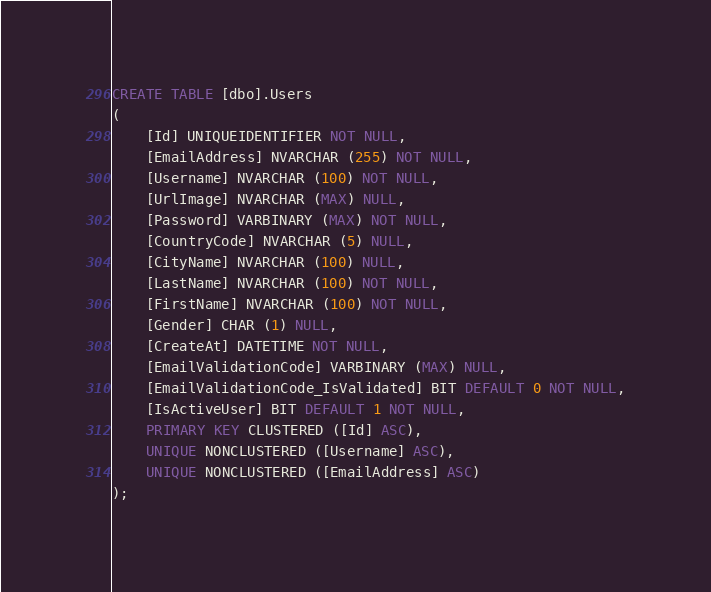<code> <loc_0><loc_0><loc_500><loc_500><_SQL_>CREATE TABLE [dbo].Users
(
    [Id] UNIQUEIDENTIFIER NOT NULL,
    [EmailAddress] NVARCHAR (255) NOT NULL,
    [Username] NVARCHAR (100) NOT NULL,
    [UrlImage] NVARCHAR (MAX) NULL,
    [Password] VARBINARY (MAX) NOT NULL,
    [CountryCode] NVARCHAR (5) NULL,
    [CityName] NVARCHAR (100) NULL,
    [LastName] NVARCHAR (100) NOT NULL,
    [FirstName] NVARCHAR (100) NOT NULL,
    [Gender] CHAR (1) NULL,
    [CreateAt] DATETIME NOT NULL,
    [EmailValidationCode] VARBINARY (MAX) NULL,
    [EmailValidationCode_IsValidated] BIT DEFAULT 0 NOT NULL,
    [IsActiveUser] BIT DEFAULT 1 NOT NULL,
    PRIMARY KEY CLUSTERED ([Id] ASC),
    UNIQUE NONCLUSTERED ([Username] ASC),
    UNIQUE NONCLUSTERED ([EmailAddress] ASC)
);</code> 